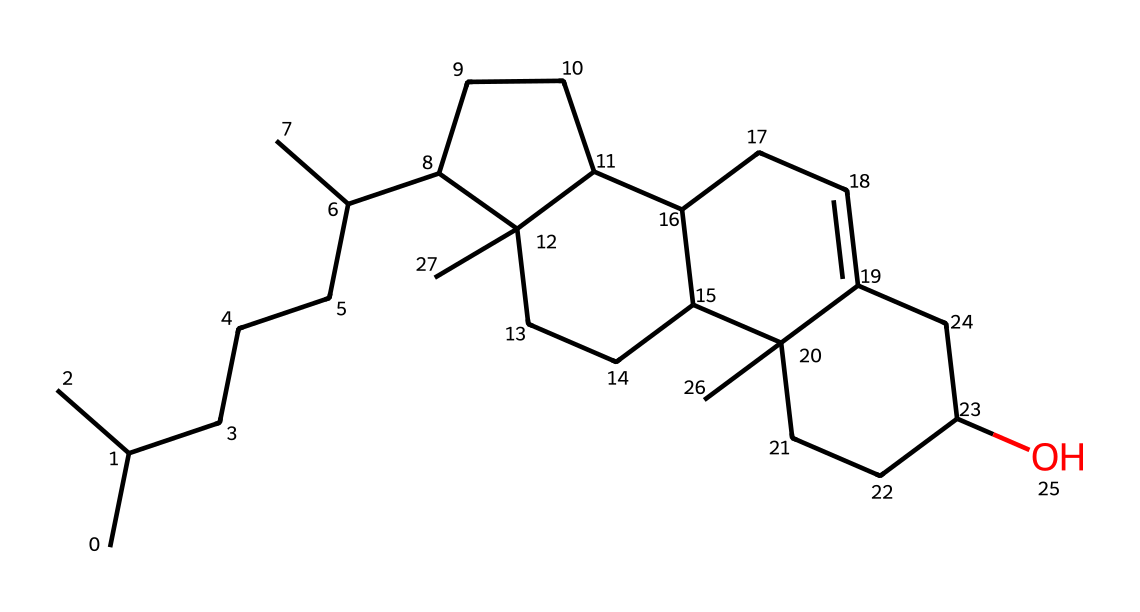What is the molecular formula of cholesterol? To determine the molecular formula, we analyze the structure for the number of carbon (C), hydrogen (H), and oxygen (O) atoms. In the provided SMILES, we can identify that there are 27 carbon atoms, 46 hydrogen atoms, and 1 oxygen atom, which gives us the molecular formula C27H46O.
Answer: C27H46O How many rings are present in the cholesterol structure? Cholesterol contains four fused rings in its structure. By visualizing the chemical structure, one can count the number of distinct cycles formed by the carbon atoms. These interconnected rings are characteristic of steroid compounds.
Answer: four What type of functional group does cholesterol contain? The presence of the hydroxyl (-OH) group in the cholesterol structure indicates it's an alcohol. Analyzing the structure reveals the atom connected to the carbon with a single bond, confirming the presence of the hydroxyl group.
Answer: alcohol How does cholesterol contribute to cell membrane fluidity? Cholesterol plays a crucial role in maintaining membrane fluidity by inserting itself between phospholipid molecules in the membrane. This inclusion prevents the fatty acid chains from packing too closely together, thus maintaining a fluid state necessary for proper cell function and stability.
Answer: fluidity What is the total number of hydrogen atoms in cholesterol? By examining the structure closely, we can count the total number of hydrogen atoms attached to the carbon skeleton. This yields a total of 46 hydrogen atoms.
Answer: 46 What is the role of the hydroxyl group in cholesterol? The hydroxyl group contributes to cholesterol's polar characteristics, allowing it to interact with the hydrophilic heads of phospholipids in the membrane. This interaction is essential for its incorporation into lipid bilayers, influencing membrane properties like flexibility and permeability.
Answer: interaction How does cholesterol affect lipid bilayer stability? Cholesterol intercalates between the fatty acid tails of the phospholipids, increasing the order of the membrane at high temperatures and preventing it from becoming too rigid at low temperatures. This dual action helps to stabilize the lipid bilayer across varying temperature conditions.
Answer: stability 